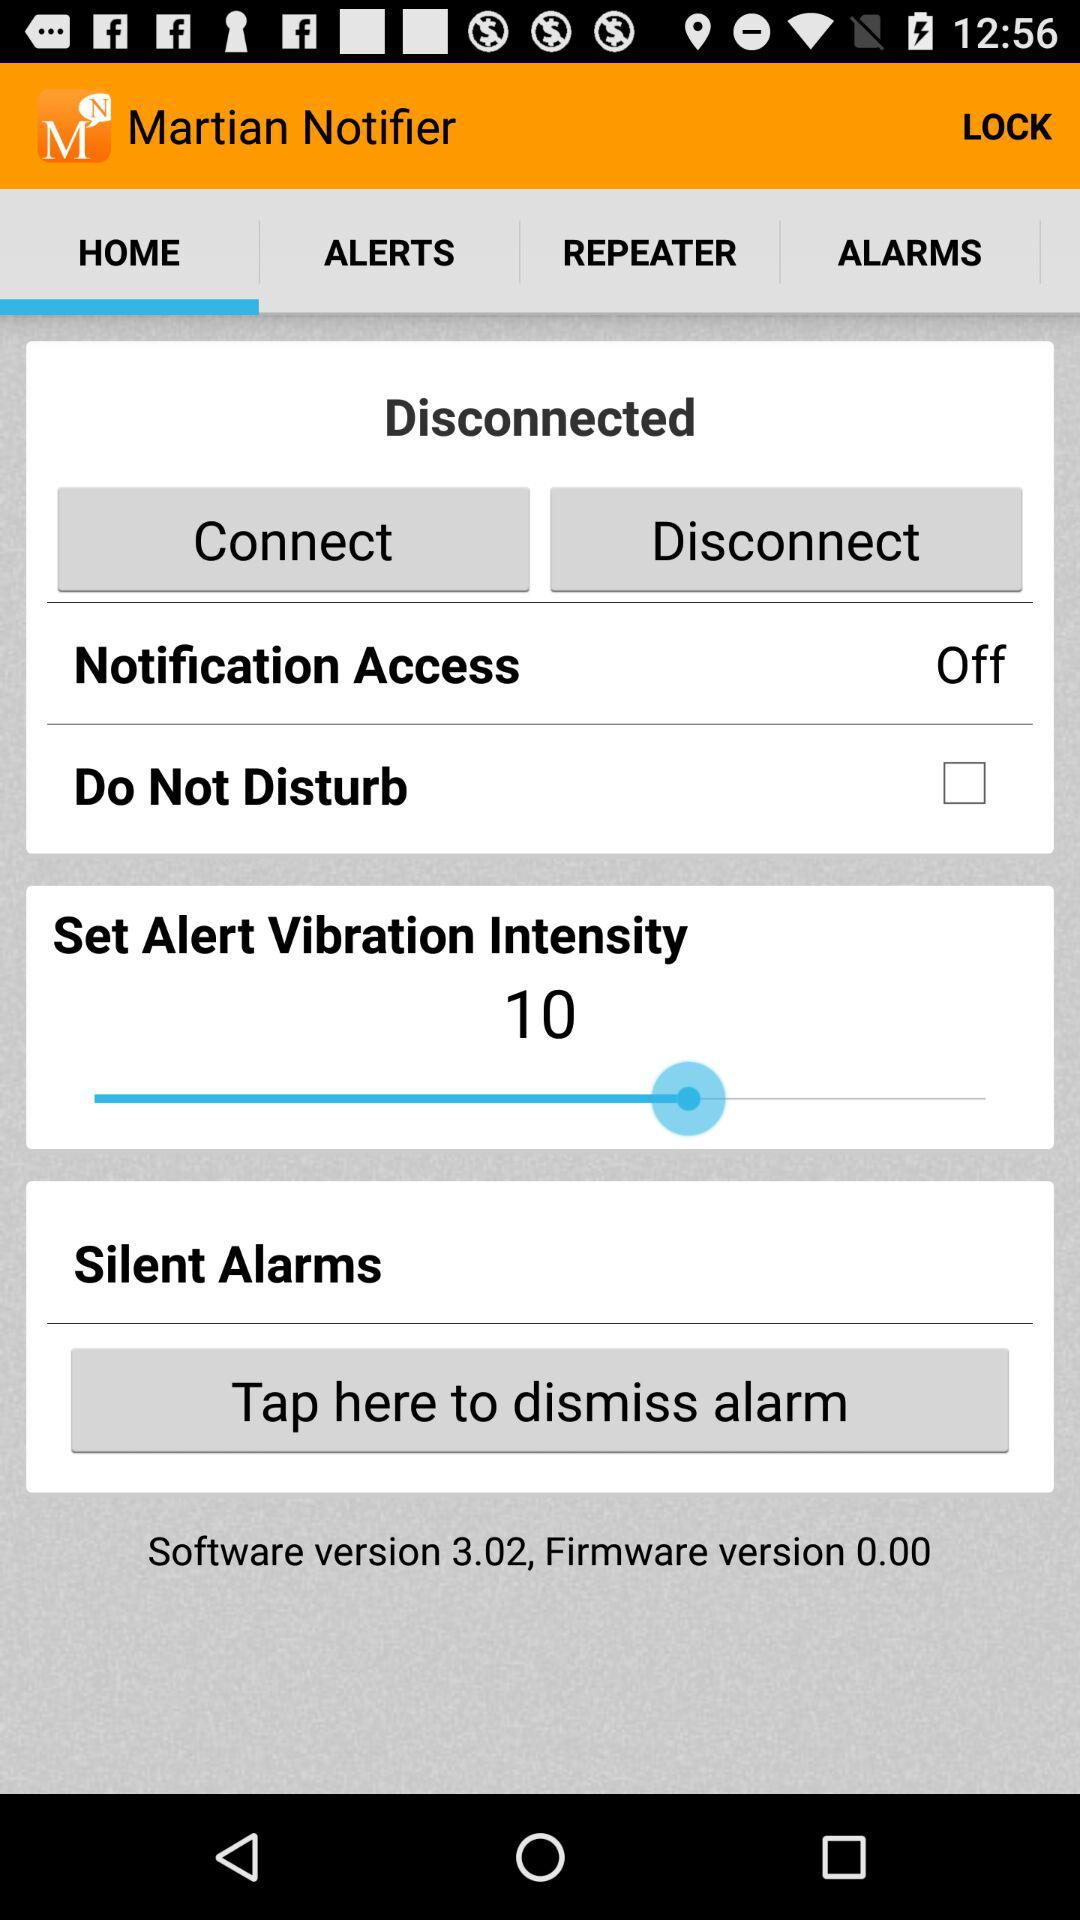What is the firmware version? The firmware version is 0.00. 